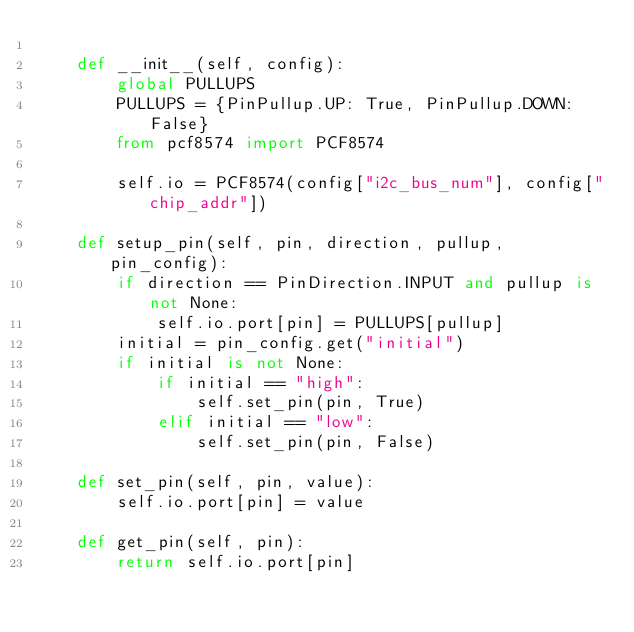Convert code to text. <code><loc_0><loc_0><loc_500><loc_500><_Python_>
    def __init__(self, config):
        global PULLUPS
        PULLUPS = {PinPullup.UP: True, PinPullup.DOWN: False}
        from pcf8574 import PCF8574

        self.io = PCF8574(config["i2c_bus_num"], config["chip_addr"])

    def setup_pin(self, pin, direction, pullup, pin_config):
        if direction == PinDirection.INPUT and pullup is not None:
            self.io.port[pin] = PULLUPS[pullup]
        initial = pin_config.get("initial")
        if initial is not None:
            if initial == "high":
                self.set_pin(pin, True)
            elif initial == "low":
                self.set_pin(pin, False)

    def set_pin(self, pin, value):
        self.io.port[pin] = value

    def get_pin(self, pin):
        return self.io.port[pin]
</code> 